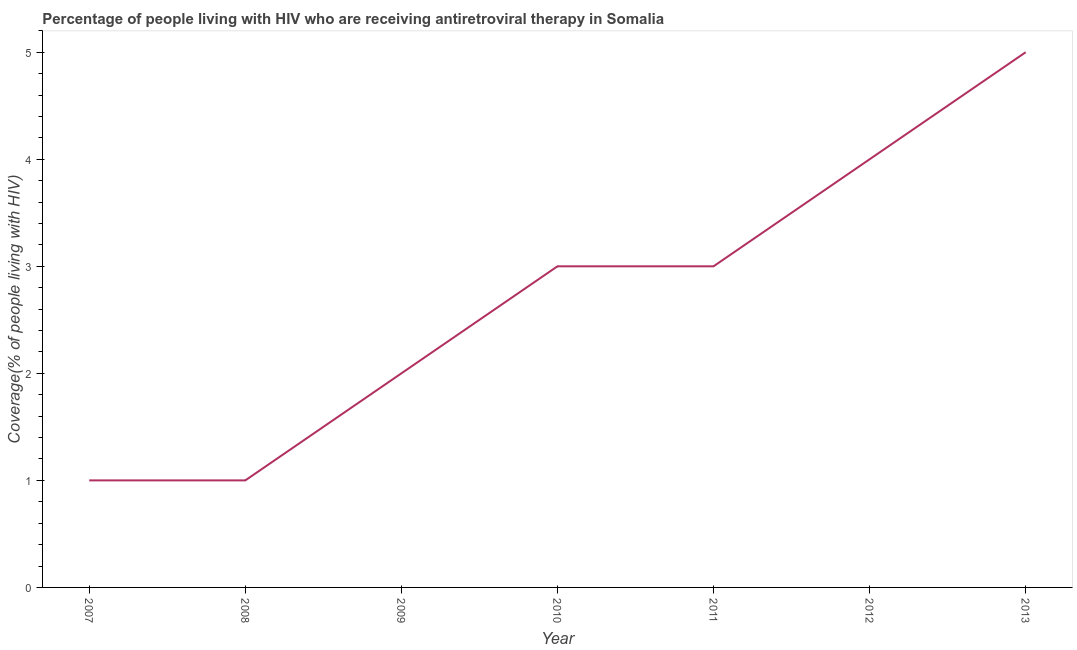What is the antiretroviral therapy coverage in 2007?
Offer a terse response. 1. Across all years, what is the maximum antiretroviral therapy coverage?
Offer a terse response. 5. Across all years, what is the minimum antiretroviral therapy coverage?
Give a very brief answer. 1. In which year was the antiretroviral therapy coverage minimum?
Give a very brief answer. 2007. What is the sum of the antiretroviral therapy coverage?
Offer a terse response. 19. What is the difference between the antiretroviral therapy coverage in 2009 and 2012?
Your response must be concise. -2. What is the average antiretroviral therapy coverage per year?
Ensure brevity in your answer.  2.71. What is the median antiretroviral therapy coverage?
Provide a succinct answer. 3. What is the ratio of the antiretroviral therapy coverage in 2008 to that in 2010?
Keep it short and to the point. 0.33. Is the sum of the antiretroviral therapy coverage in 2012 and 2013 greater than the maximum antiretroviral therapy coverage across all years?
Your response must be concise. Yes. What is the difference between the highest and the lowest antiretroviral therapy coverage?
Offer a very short reply. 4. In how many years, is the antiretroviral therapy coverage greater than the average antiretroviral therapy coverage taken over all years?
Your answer should be very brief. 4. Does the antiretroviral therapy coverage monotonically increase over the years?
Make the answer very short. No. What is the title of the graph?
Make the answer very short. Percentage of people living with HIV who are receiving antiretroviral therapy in Somalia. What is the label or title of the Y-axis?
Your answer should be compact. Coverage(% of people living with HIV). What is the Coverage(% of people living with HIV) in 2008?
Offer a terse response. 1. What is the Coverage(% of people living with HIV) of 2013?
Your response must be concise. 5. What is the difference between the Coverage(% of people living with HIV) in 2007 and 2009?
Your response must be concise. -1. What is the difference between the Coverage(% of people living with HIV) in 2007 and 2010?
Ensure brevity in your answer.  -2. What is the difference between the Coverage(% of people living with HIV) in 2007 and 2012?
Your answer should be compact. -3. What is the difference between the Coverage(% of people living with HIV) in 2008 and 2009?
Your response must be concise. -1. What is the difference between the Coverage(% of people living with HIV) in 2008 and 2012?
Provide a succinct answer. -3. What is the difference between the Coverage(% of people living with HIV) in 2008 and 2013?
Keep it short and to the point. -4. What is the difference between the Coverage(% of people living with HIV) in 2009 and 2010?
Your response must be concise. -1. What is the difference between the Coverage(% of people living with HIV) in 2009 and 2013?
Provide a short and direct response. -3. What is the difference between the Coverage(% of people living with HIV) in 2010 and 2011?
Your response must be concise. 0. What is the ratio of the Coverage(% of people living with HIV) in 2007 to that in 2009?
Offer a very short reply. 0.5. What is the ratio of the Coverage(% of people living with HIV) in 2007 to that in 2010?
Keep it short and to the point. 0.33. What is the ratio of the Coverage(% of people living with HIV) in 2007 to that in 2011?
Offer a terse response. 0.33. What is the ratio of the Coverage(% of people living with HIV) in 2007 to that in 2012?
Give a very brief answer. 0.25. What is the ratio of the Coverage(% of people living with HIV) in 2008 to that in 2010?
Ensure brevity in your answer.  0.33. What is the ratio of the Coverage(% of people living with HIV) in 2008 to that in 2011?
Provide a succinct answer. 0.33. What is the ratio of the Coverage(% of people living with HIV) in 2008 to that in 2012?
Provide a short and direct response. 0.25. What is the ratio of the Coverage(% of people living with HIV) in 2009 to that in 2010?
Give a very brief answer. 0.67. What is the ratio of the Coverage(% of people living with HIV) in 2009 to that in 2011?
Provide a succinct answer. 0.67. What is the ratio of the Coverage(% of people living with HIV) in 2010 to that in 2011?
Your response must be concise. 1. What is the ratio of the Coverage(% of people living with HIV) in 2010 to that in 2012?
Provide a succinct answer. 0.75. What is the ratio of the Coverage(% of people living with HIV) in 2012 to that in 2013?
Ensure brevity in your answer.  0.8. 